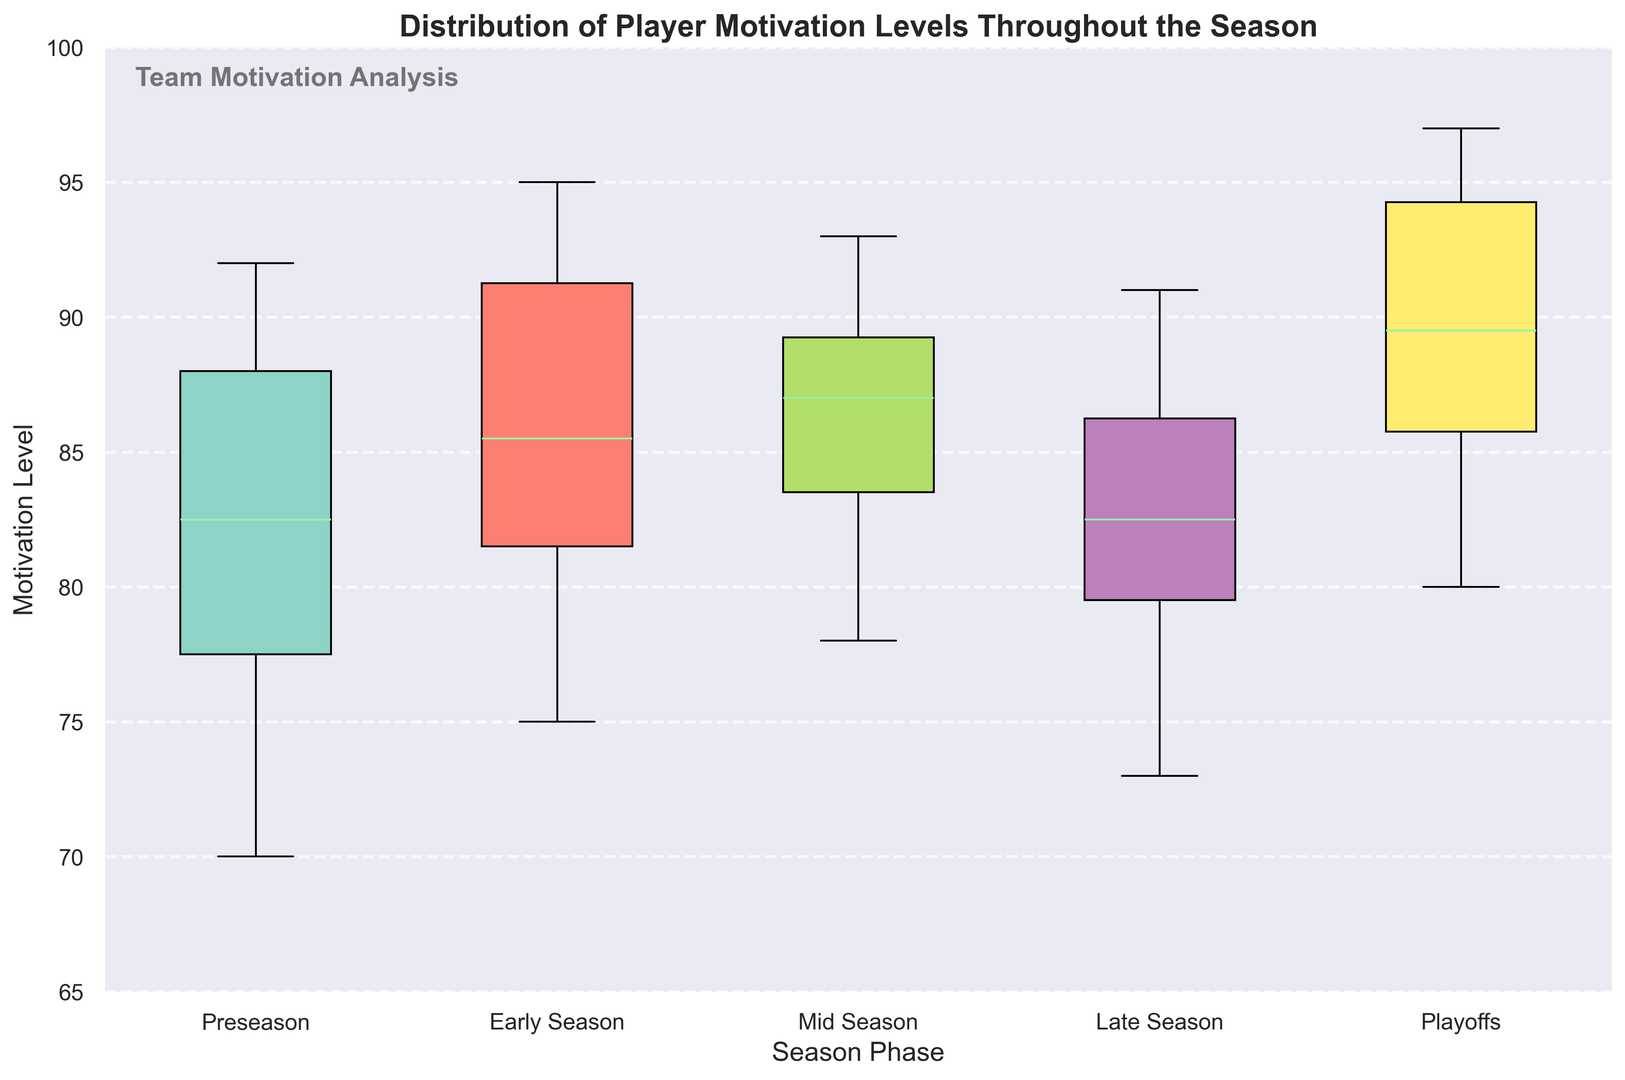Which season phase has the highest median motivation level? The median value is denoted by the line inside each box. By observing the plot, the Playoffs phase has the highest median motivation level.
Answer: Playoffs How does the interquartile range (IQR) of the Mid Season compare to the Early Season? The IQR is the range between the first (Q1) and third quartiles (Q3) of each box plot. The width of the box for the Mid Season is slightly smaller than the Early Season. This indicates the Mid Season IQR is narrower compared to the Early Season.
Answer: Mid Season IQR is narrower Which season phase has the smallest range of motivation levels? The range is the distance between the minimum and maximum points. The Late Season phase has the smallest range as its whiskers are the closest together.
Answer: Late Season Is there an outlier in the Playoffs phase? Outliers are typically represented as individual points outside the whiskers. There are no individual points beyond the whiskers in the Playoffs phase, indicating no outliers.
Answer: No What is the median motivation level during the Mid Season? The median value is the line inside the Mid Season box. By viewing the plot, the median is approximately 88.
Answer: 88 Between Preseason and Late Season, which has the higher minimum motivation level? The minimum value is at the bottom whisker of each box plot. By comparing the whiskers, Preseason has a higher minimum motivation level, around 70, compared to the Late Season minimum around 76.
Answer: Late Season How does the average motivation level during Late Season compare to the Playoffs? Although the exact average is not given, we can approximate by looking at the boxes. Late Season has slightly lower boxes than the Playoffs, indicating that the average motivation level during the Playoffs is generally higher than during the Late Season.
Answer: Playoffs is higher Is the variability of motivation levels higher in Preseason or Early Season? Variability can be inferred from the spread of the box and whiskers. The Early Season shows a slightly larger spread in its box and whiskers, indicating higher variability compared to Preseason.
Answer: Early Season Which phase shows the greatest improvement in median motivation level from Preseason? Comparing the median lines from each box plot, Playoffs shows the greatest improvement in the median motivation level from Preseason.
Answer: Playoffs 